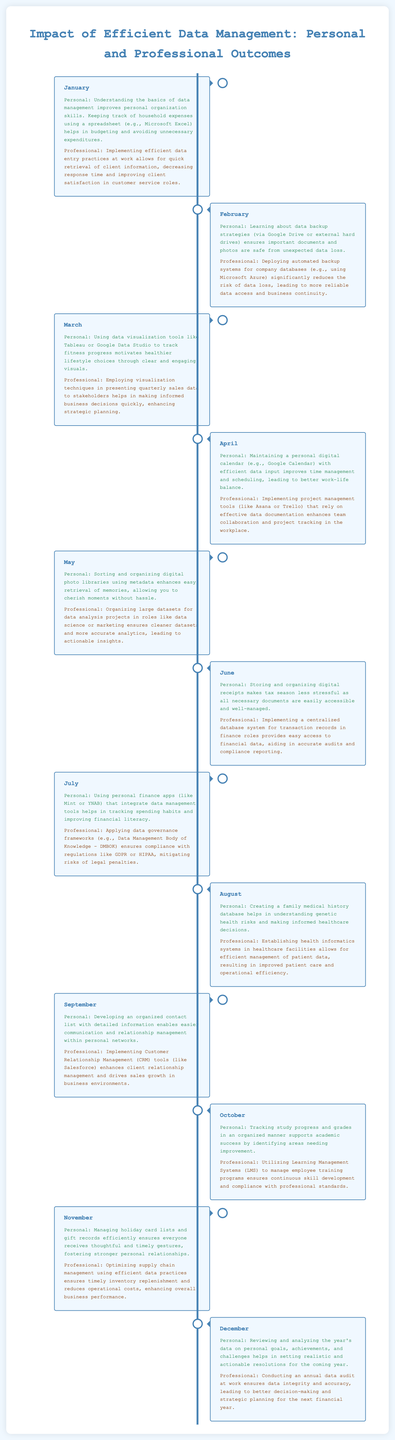What was the personal outcome for January? The personal outcome for January is about understanding the basics of data management improving personal organization skills and tracking household expenses using a spreadsheet for budgeting.
Answer: Understanding the basics of data management improves personal organization skills What professional outcome is highlighted for March? The professional outcome for March describes the use of visualization techniques in presenting quarterly sales data to stakeholders, facilitating informed business decisions.
Answer: Employing visualization techniques in presenting quarterly sales data What is a personal benefit of using digital receipts mentioned in June? The personal benefit of using digital receipts is making tax season less stressful because necessary documents are easily accessible and well-managed.
Answer: Makes tax season less stressful Which month emphasizes the importance of data backup strategies for personal document safety? The month that emphasizes the importance of data backup strategies is February, focusing on ensuring important documents and photos are safe from data loss.
Answer: February How does July's professional outcome relate to legal compliance? July's professional outcome relates to applying data governance frameworks to ensure compliance with regulations, mitigating risks of legal penalties.
Answer: Ensures compliance with regulations What month suggests using a family medical history database? The month that suggests using a family medical history database is August, highlighting its role in understanding genetic health risks.
Answer: August What outcome is linked to the use of Learning Management Systems in October? The outcome linked to Learning Management Systems in October is managing employee training programs to ensure continuous skill development.
Answer: Ensures continuous skill development What is the overall theme of the December outcomes? The overall theme of the December outcomes is reviewing and conducting audits for personal and professional data to enhance future planning.
Answer: Reviewing and conducting audits 